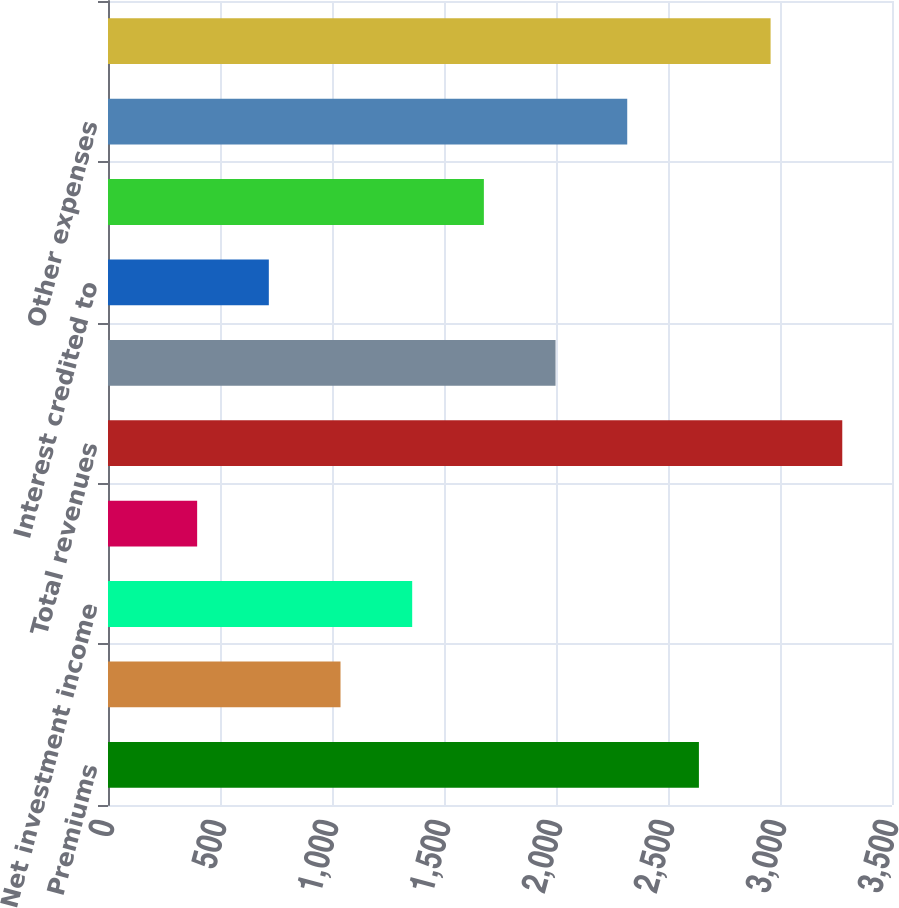Convert chart. <chart><loc_0><loc_0><loc_500><loc_500><bar_chart><fcel>Premiums<fcel>Universal life and<fcel>Net investment income<fcel>Other revenues<fcel>Total revenues<fcel>Policyholder benefits and<fcel>Interest credited to<fcel>Amortization of DAC and VOBA<fcel>Other expenses<fcel>Total expenses<nl><fcel>2638<fcel>1038<fcel>1358<fcel>398<fcel>3278<fcel>1998<fcel>718<fcel>1678<fcel>2318<fcel>2958<nl></chart> 